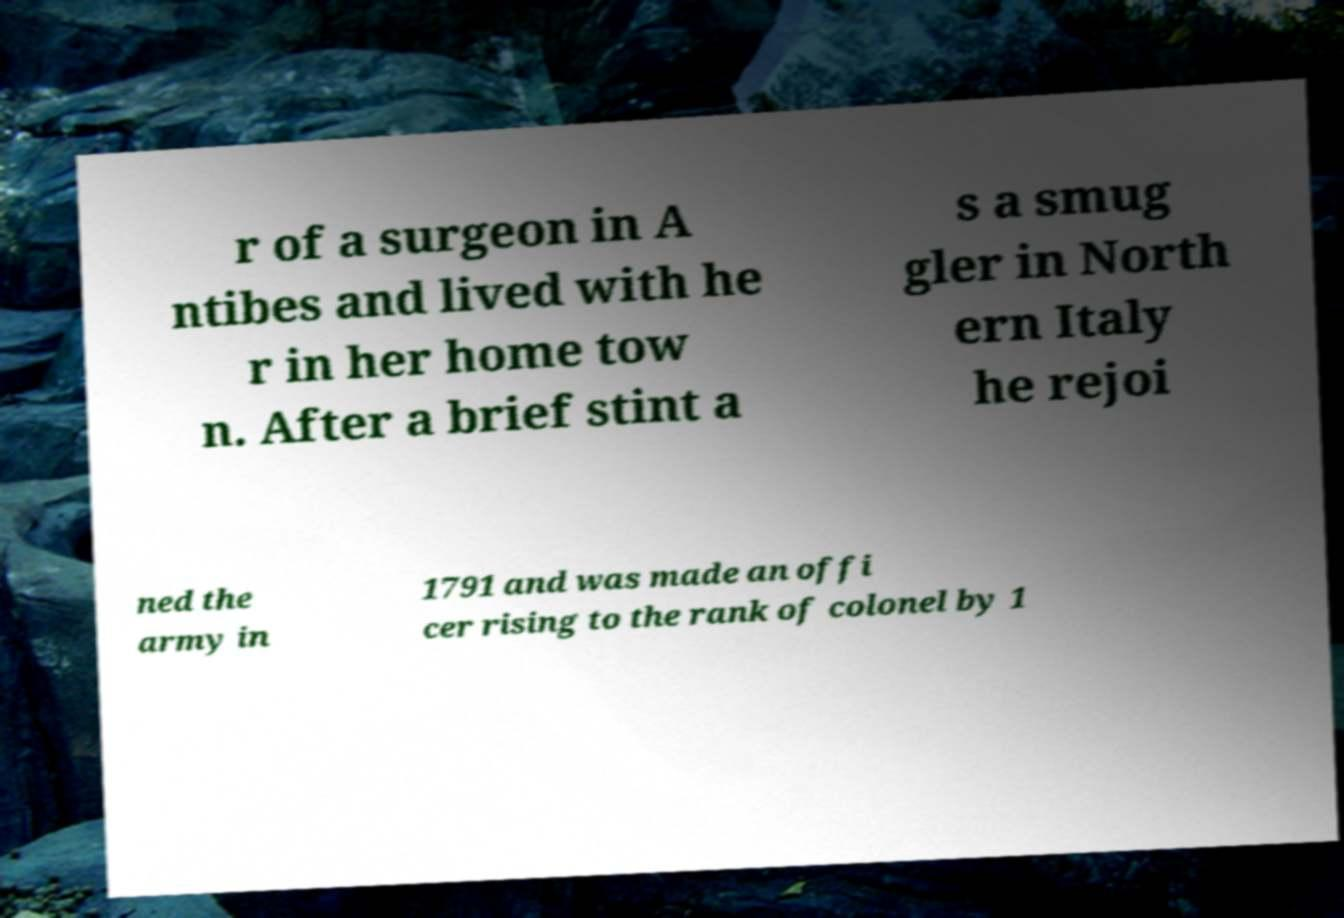I need the written content from this picture converted into text. Can you do that? r of a surgeon in A ntibes and lived with he r in her home tow n. After a brief stint a s a smug gler in North ern Italy he rejoi ned the army in 1791 and was made an offi cer rising to the rank of colonel by 1 